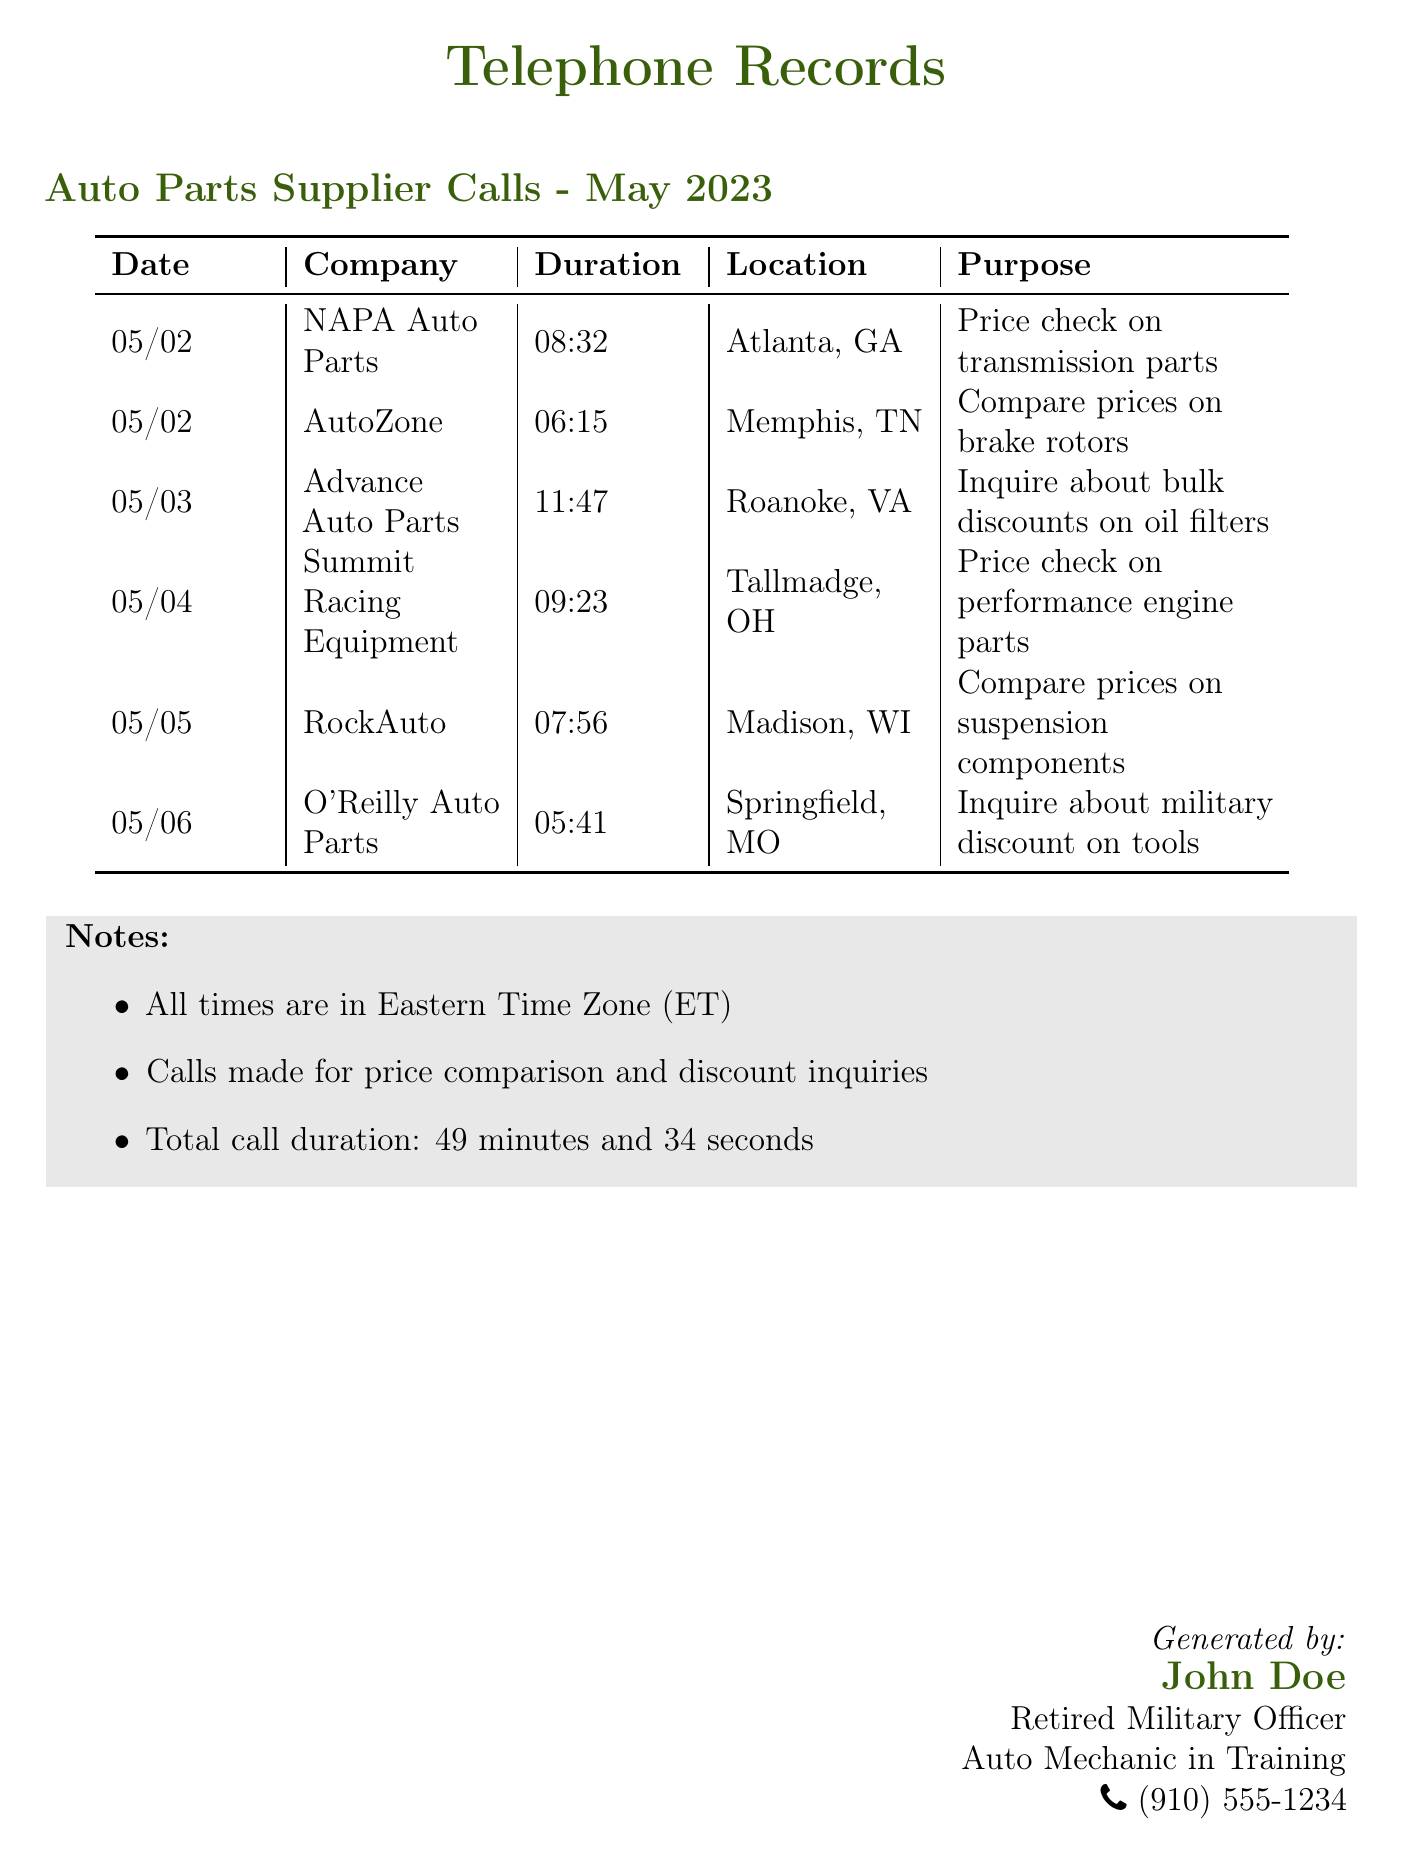what is the total call duration? The total call duration is stated in the document as the sum of all call durations, which is 49 minutes and 34 seconds.
Answer: 49 minutes and 34 seconds how many calls were made on May 2nd? The document lists two calls made on May 2nd: one to NAPA Auto Parts and one to AutoZone.
Answer: 2 calls which company was called on May 3rd? The entry for May 3rd indicates that Advance Auto Parts was called.
Answer: Advance Auto Parts what was the purpose of the call to O'Reilly Auto Parts? The document states that the purpose of the call to O'Reilly Auto Parts was to inquire about military discounts on tools.
Answer: Inquire about military discount on tools which location had the longest call duration? By examining the call durations, the longest call was to Advance Auto Parts, lasting 11 minutes and 47 seconds.
Answer: Roanoke, VA who generated this document? The document specifies that John Doe generated this telephone records document.
Answer: John Doe how many auto parts suppliers were called in total? The total number of auto parts suppliers called, as listed in the document, is six.
Answer: 6 which supplier was contacted for performance engine parts? The document indicates that the call for performance engine parts was made to Summit Racing Equipment.
Answer: Summit Racing Equipment 